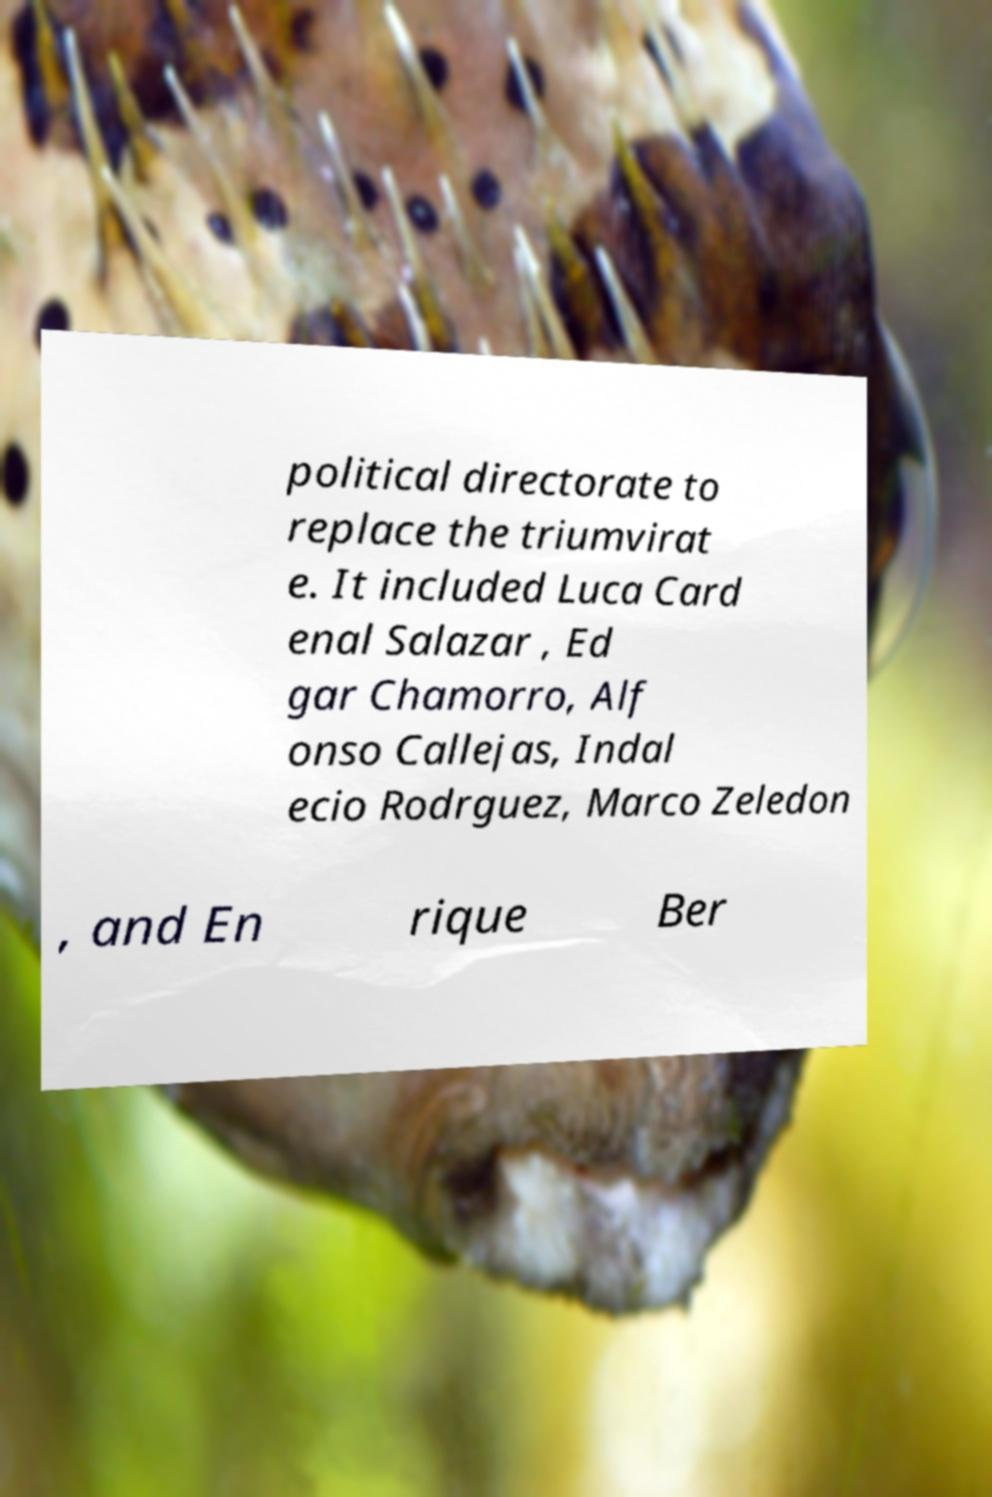Please identify and transcribe the text found in this image. political directorate to replace the triumvirat e. It included Luca Card enal Salazar , Ed gar Chamorro, Alf onso Callejas, Indal ecio Rodrguez, Marco Zeledon , and En rique Ber 